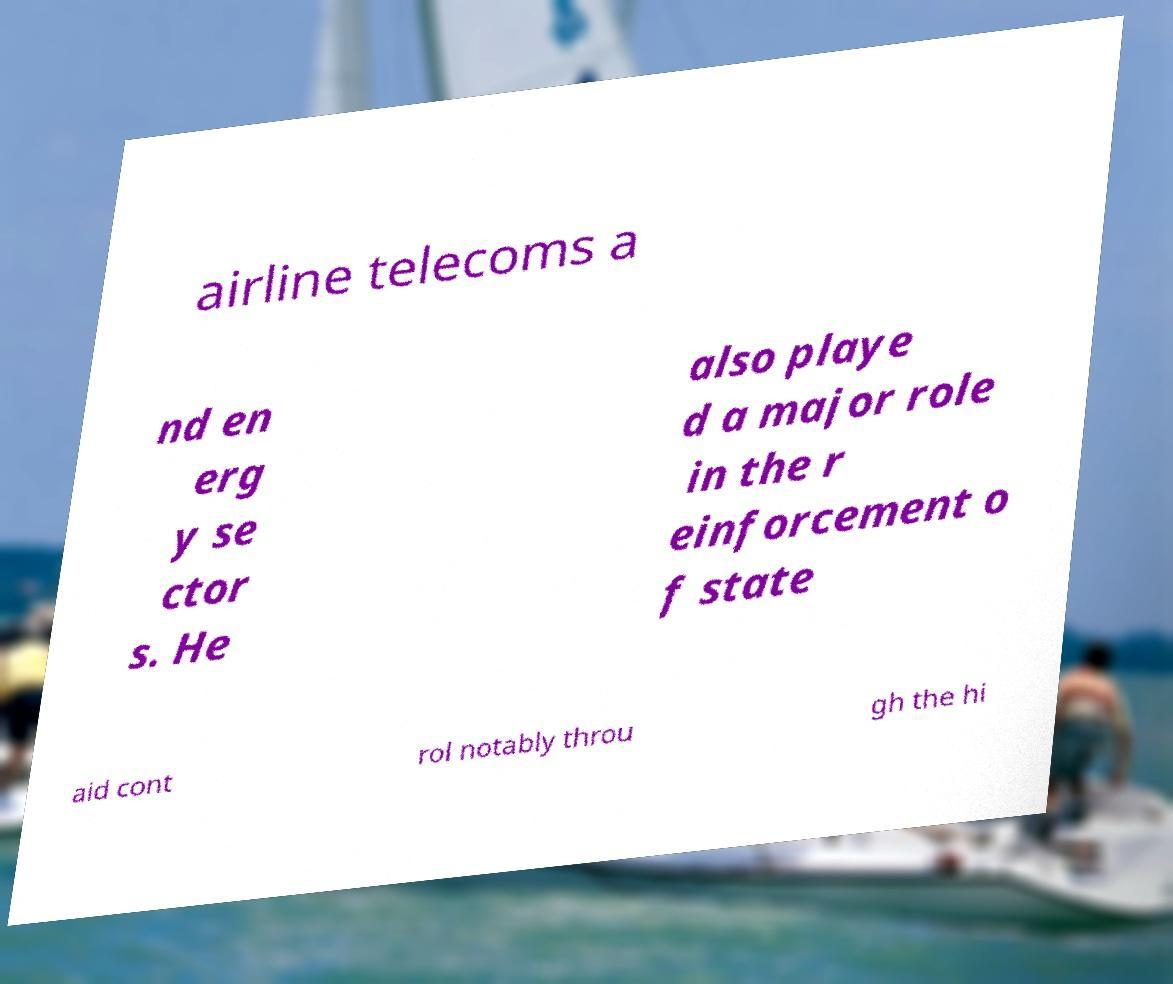Could you extract and type out the text from this image? airline telecoms a nd en erg y se ctor s. He also playe d a major role in the r einforcement o f state aid cont rol notably throu gh the hi 